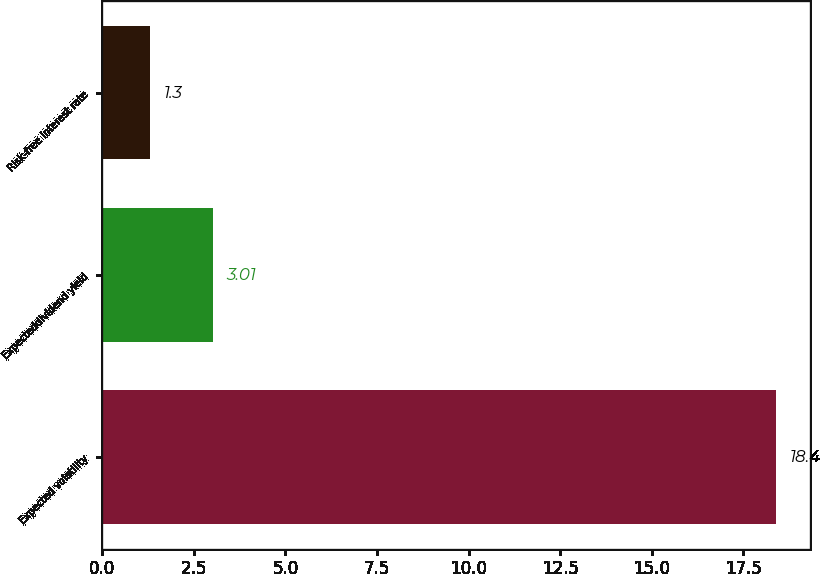Convert chart to OTSL. <chart><loc_0><loc_0><loc_500><loc_500><bar_chart><fcel>Expected volatility<fcel>Expecteddividend yield<fcel>Risk-free interest rate<nl><fcel>18.4<fcel>3.01<fcel>1.3<nl></chart> 